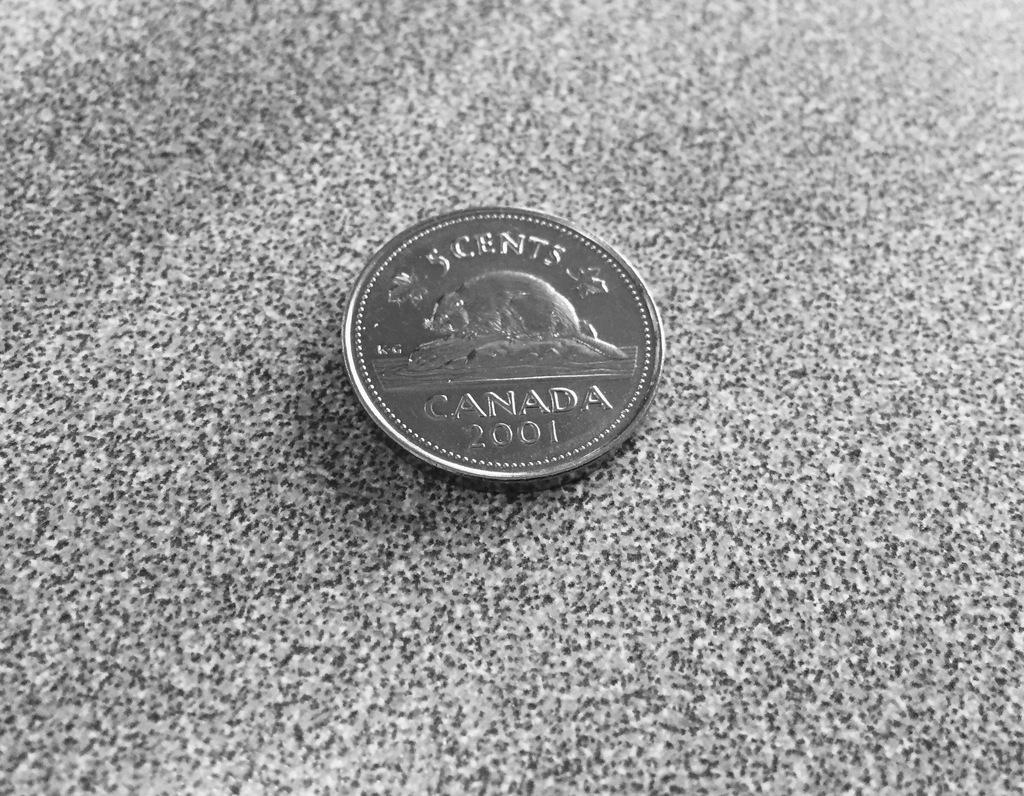<image>
Create a compact narrative representing the image presented. A 5 cents coin with the word Canada on it 